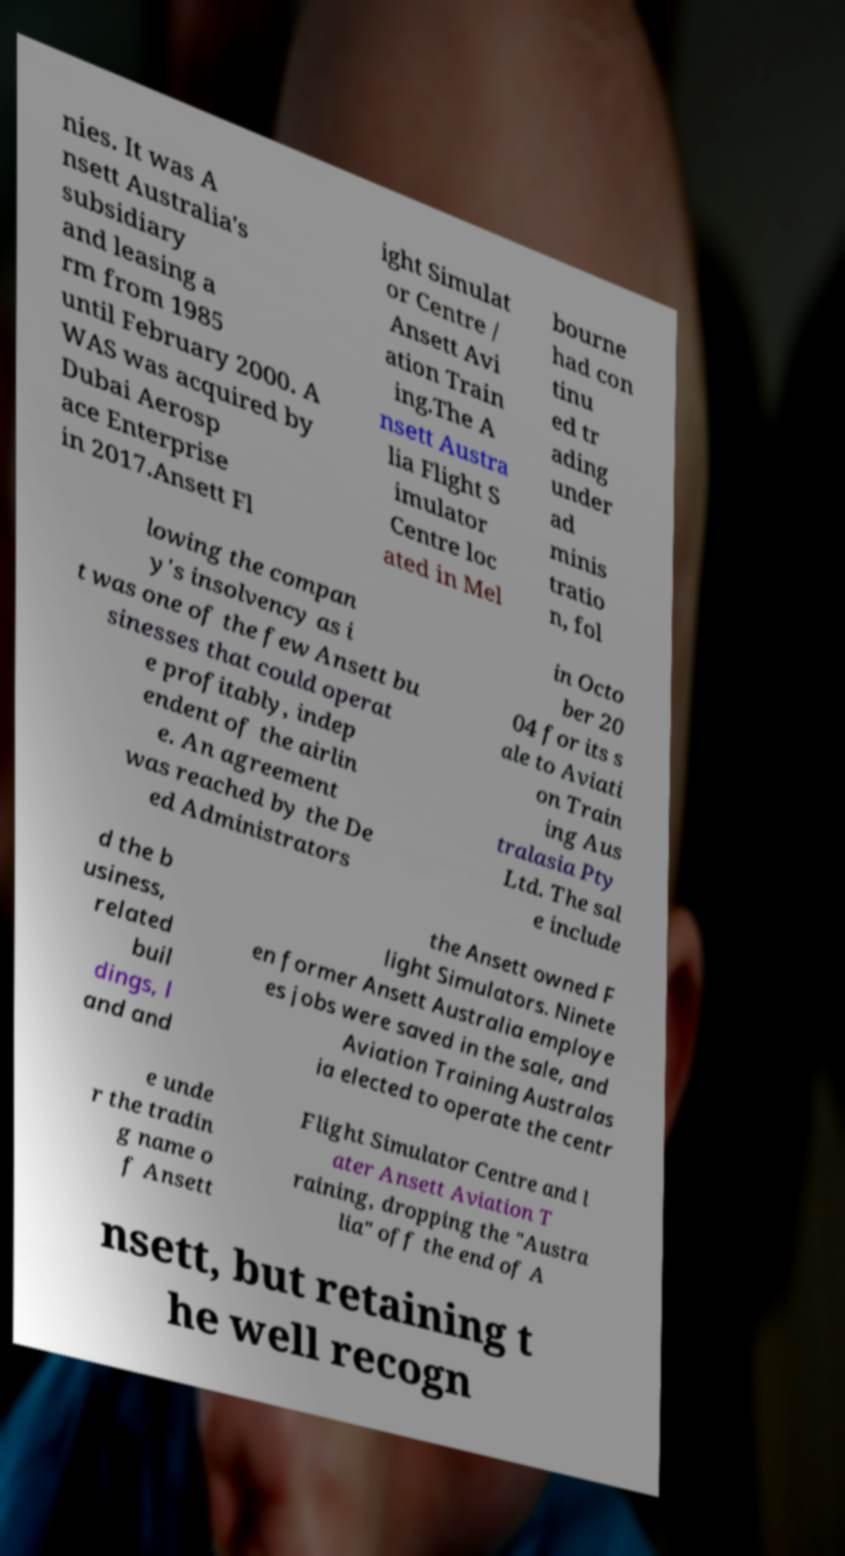Can you read and provide the text displayed in the image?This photo seems to have some interesting text. Can you extract and type it out for me? nies. It was A nsett Australia's subsidiary and leasing a rm from 1985 until February 2000. A WAS was acquired by Dubai Aerosp ace Enterprise in 2017.Ansett Fl ight Simulat or Centre / Ansett Avi ation Train ing.The A nsett Austra lia Flight S imulator Centre loc ated in Mel bourne had con tinu ed tr ading under ad minis tratio n, fol lowing the compan y's insolvency as i t was one of the few Ansett bu sinesses that could operat e profitably, indep endent of the airlin e. An agreement was reached by the De ed Administrators in Octo ber 20 04 for its s ale to Aviati on Train ing Aus tralasia Pty Ltd. The sal e include d the b usiness, related buil dings, l and and the Ansett owned F light Simulators. Ninete en former Ansett Australia employe es jobs were saved in the sale, and Aviation Training Australas ia elected to operate the centr e unde r the tradin g name o f Ansett Flight Simulator Centre and l ater Ansett Aviation T raining, dropping the "Austra lia" off the end of A nsett, but retaining t he well recogn 